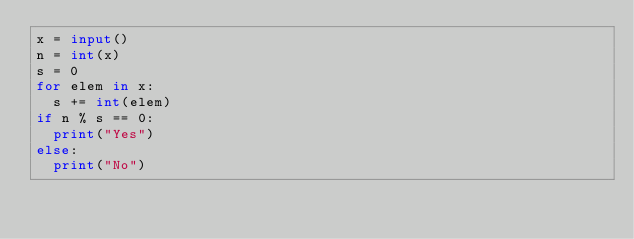Convert code to text. <code><loc_0><loc_0><loc_500><loc_500><_Python_>x = input()
n = int(x)
s = 0
for elem in x:
  s += int(elem)
if n % s == 0:
  print("Yes")
else:
  print("No")</code> 